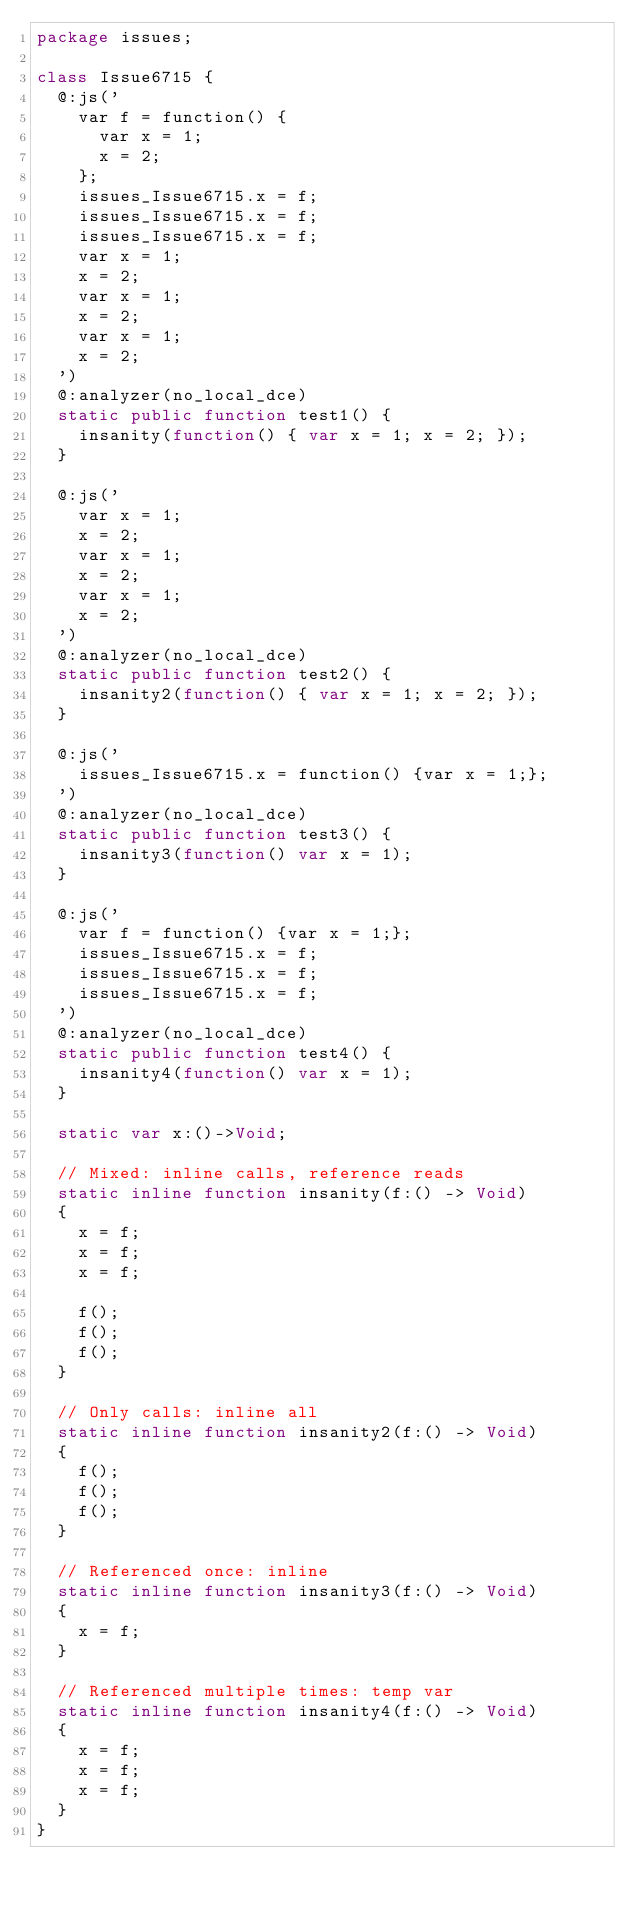Convert code to text. <code><loc_0><loc_0><loc_500><loc_500><_Haxe_>package issues;

class Issue6715 {
	@:js('
		var f = function() {
			var x = 1;
			x = 2;
		};
		issues_Issue6715.x = f;
		issues_Issue6715.x = f;
		issues_Issue6715.x = f;
		var x = 1;
		x = 2;
		var x = 1;
		x = 2;
		var x = 1;
		x = 2;
	')
	@:analyzer(no_local_dce)
	static public function test1() {
		insanity(function() { var x = 1; x = 2; });
	}

	@:js('
		var x = 1;
		x = 2;
		var x = 1;
		x = 2;
		var x = 1;
		x = 2;
	')
	@:analyzer(no_local_dce)
	static public function test2() {
		insanity2(function() { var x = 1; x = 2; });
	}

	@:js('
		issues_Issue6715.x = function() {var x = 1;};
	')
	@:analyzer(no_local_dce)
	static public function test3() {
		insanity3(function() var x = 1);
	}

	@:js('
		var f = function() {var x = 1;};
		issues_Issue6715.x = f;
		issues_Issue6715.x = f;
		issues_Issue6715.x = f;
	')
	@:analyzer(no_local_dce)
	static public function test4() {
		insanity4(function() var x = 1);
	}

	static var x:()->Void;

	// Mixed: inline calls, reference reads
	static inline function insanity(f:() -> Void)
	{
		x = f;
		x = f;
		x = f;

		f();
		f();
		f();
	}

	// Only calls: inline all
	static inline function insanity2(f:() -> Void)
	{
		f();
		f();
		f();
	}

	// Referenced once: inline
	static inline function insanity3(f:() -> Void)
	{
		x = f;
	}

	// Referenced multiple times: temp var
	static inline function insanity4(f:() -> Void)
	{
		x = f;
		x = f;
		x = f;
	}
}</code> 